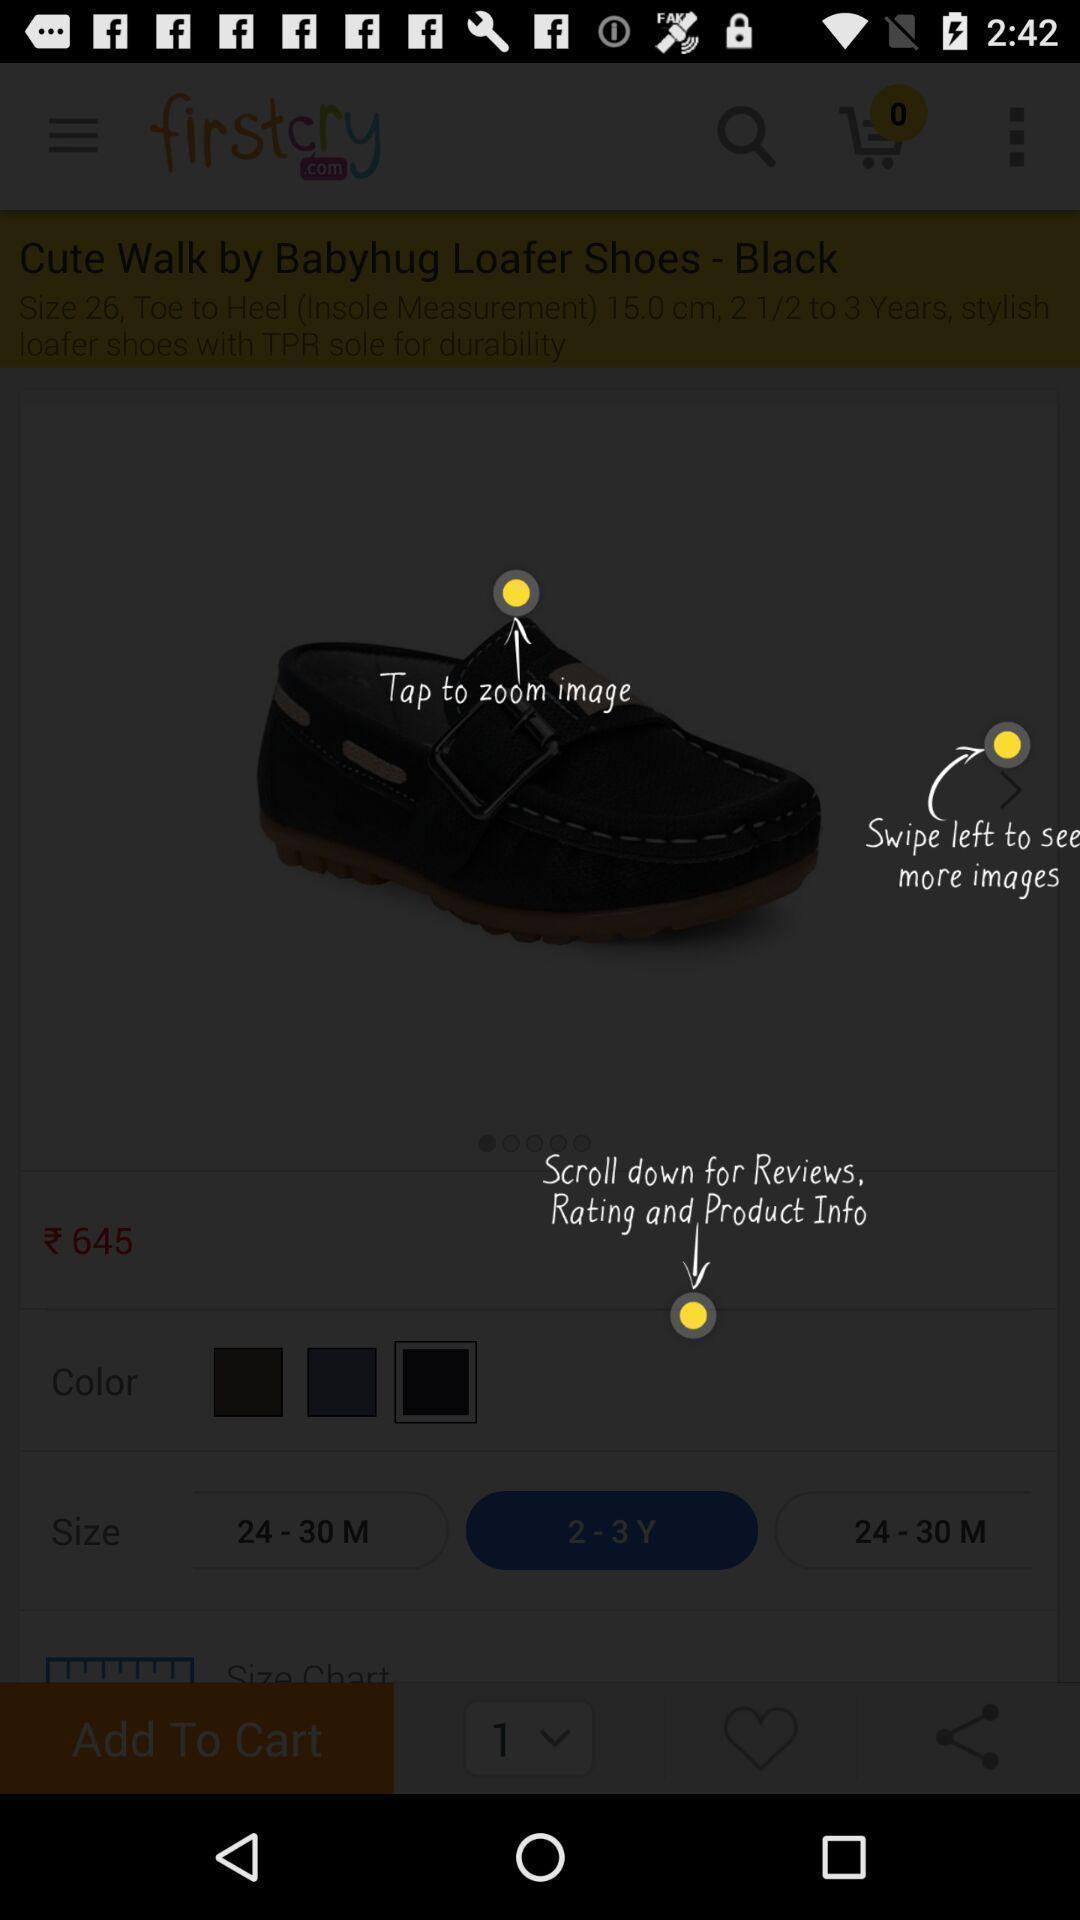Tell me what you see in this picture. Page showing instructions to use a shopping app. 